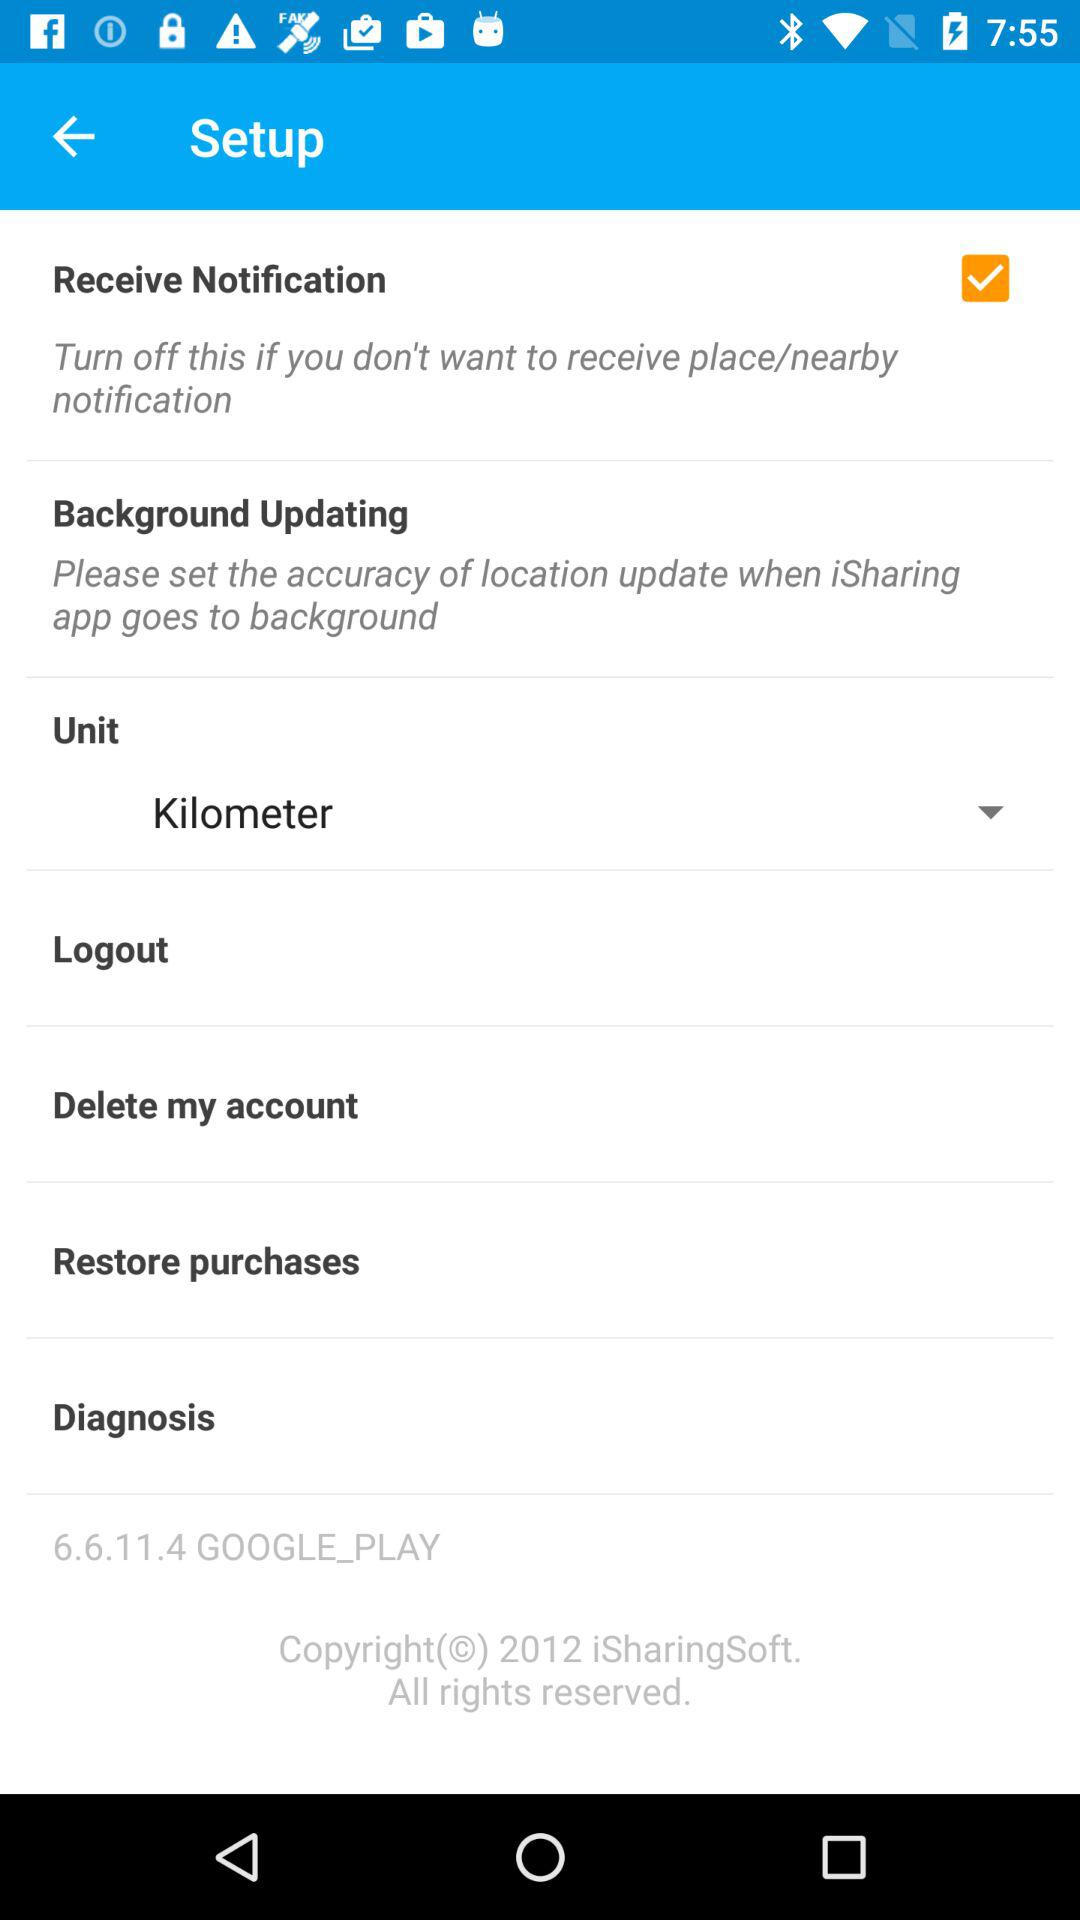What is the status of "Receive Notification"? Thee status is "on". 